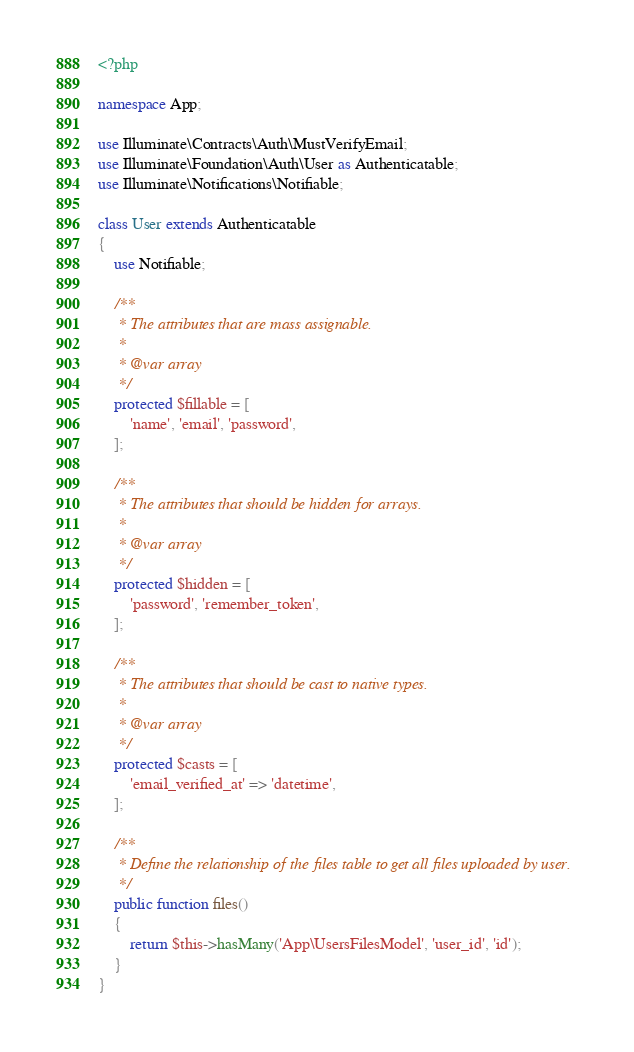Convert code to text. <code><loc_0><loc_0><loc_500><loc_500><_PHP_><?php

namespace App;

use Illuminate\Contracts\Auth\MustVerifyEmail;
use Illuminate\Foundation\Auth\User as Authenticatable;
use Illuminate\Notifications\Notifiable;

class User extends Authenticatable
{
    use Notifiable;

    /**
     * The attributes that are mass assignable.
     *
     * @var array
     */
    protected $fillable = [
        'name', 'email', 'password',
    ];

    /**
     * The attributes that should be hidden for arrays.
     *
     * @var array
     */
    protected $hidden = [
        'password', 'remember_token',
    ];

    /**
     * The attributes that should be cast to native types.
     *
     * @var array
     */
    protected $casts = [
        'email_verified_at' => 'datetime',
    ];

    /**
     * Define the relationship of the files table to get all files uploaded by user.
     */
    public function files()
    {
        return $this->hasMany('App\UsersFilesModel', 'user_id', 'id');
    }
}
</code> 